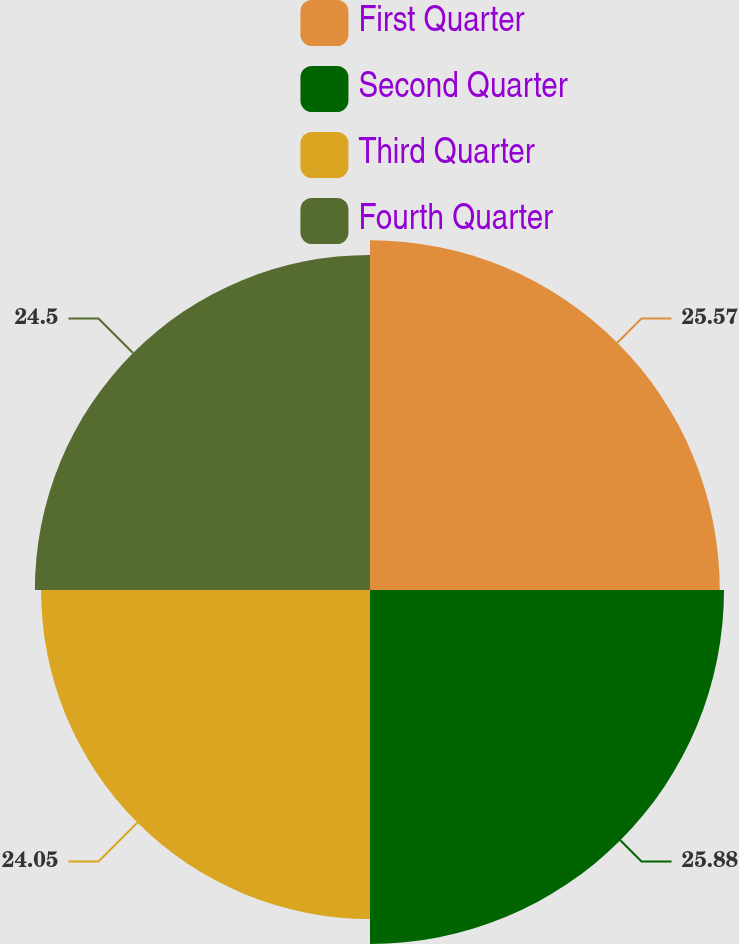<chart> <loc_0><loc_0><loc_500><loc_500><pie_chart><fcel>First Quarter<fcel>Second Quarter<fcel>Third Quarter<fcel>Fourth Quarter<nl><fcel>25.57%<fcel>25.88%<fcel>24.05%<fcel>24.5%<nl></chart> 